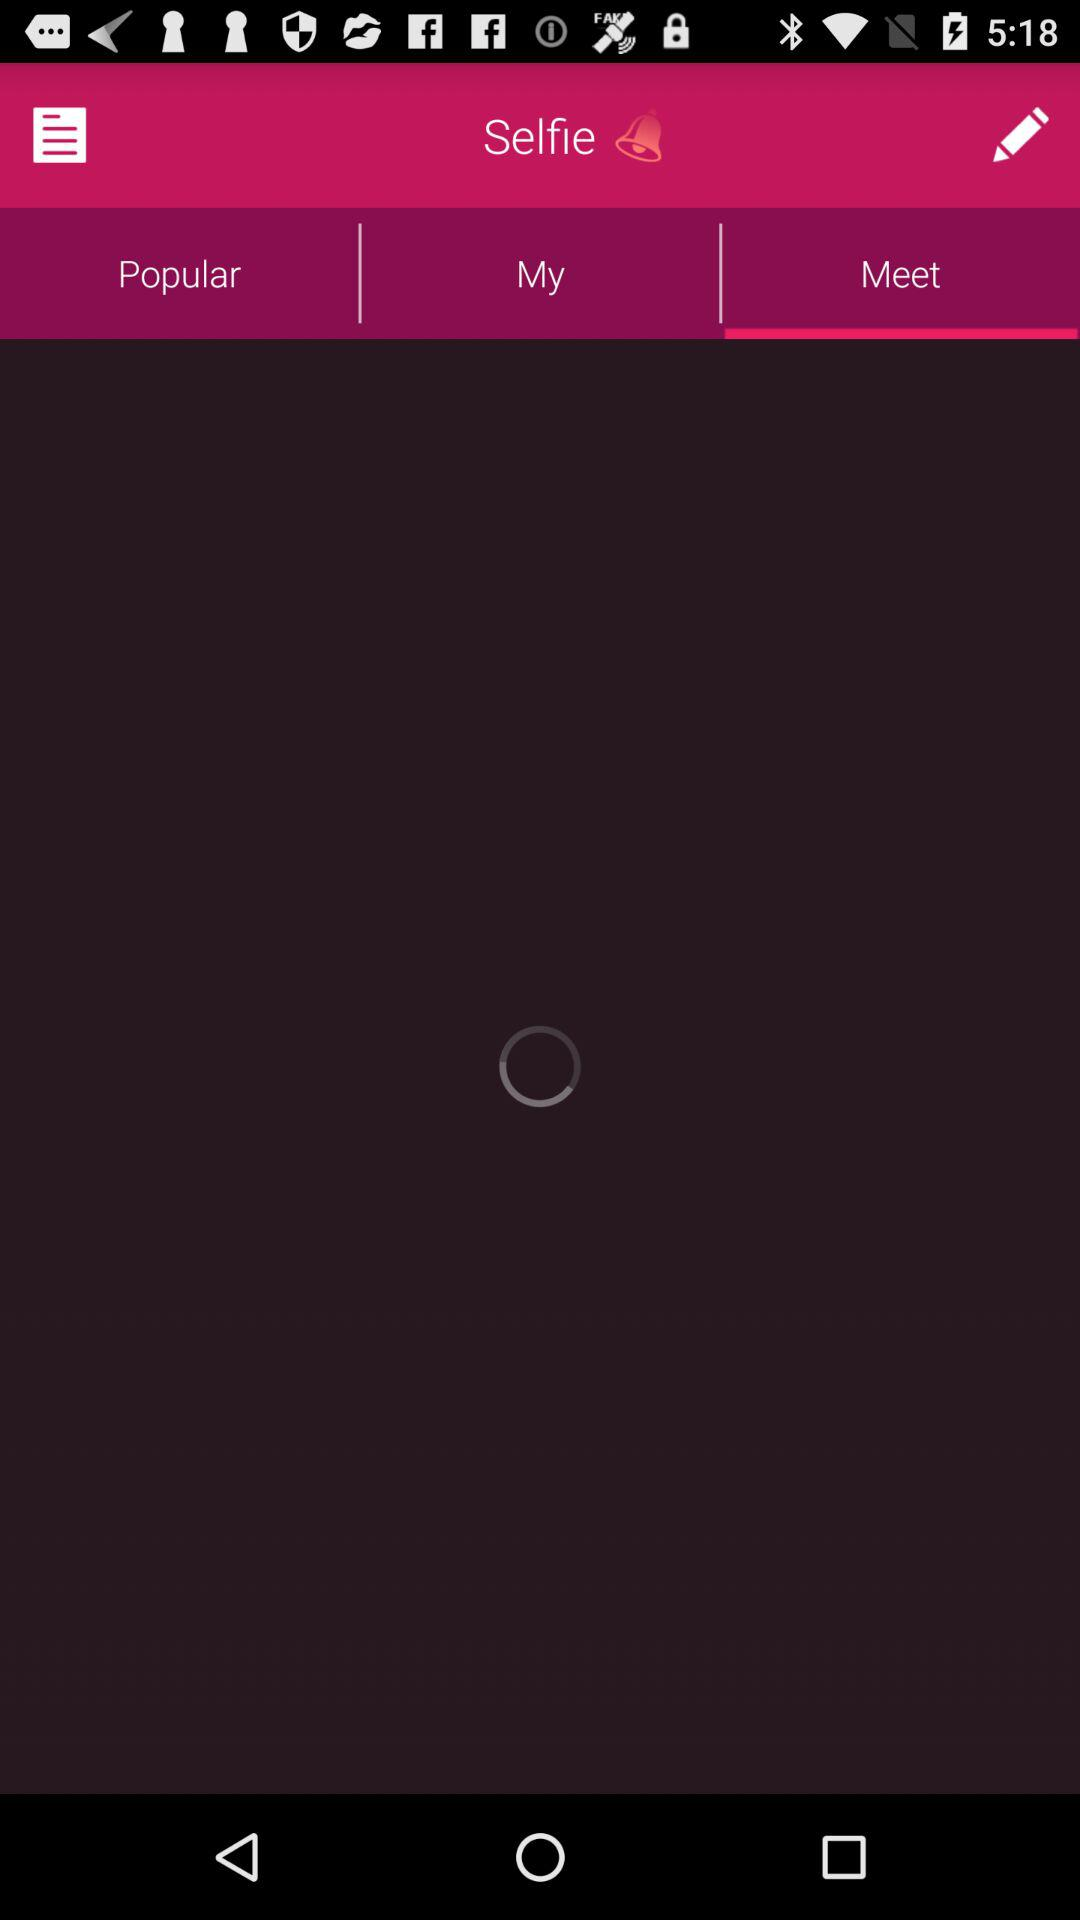Which tab am I on? You are on "Meet" tab. 